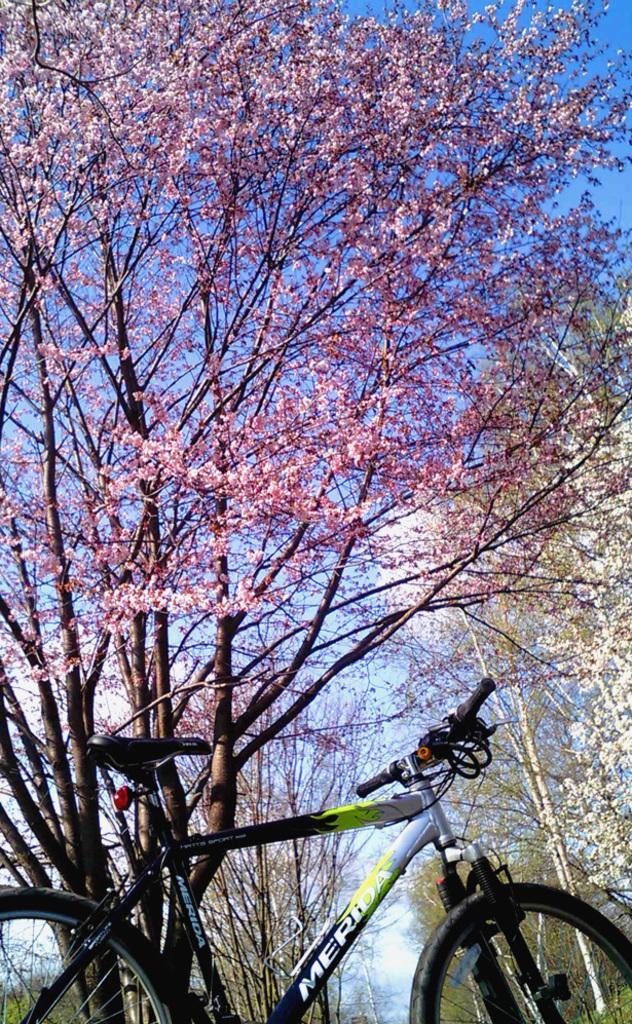How would you summarize this image in a sentence or two? In this picture I can see the bicycle. I can see trees. I can see the clouds in the sky. 